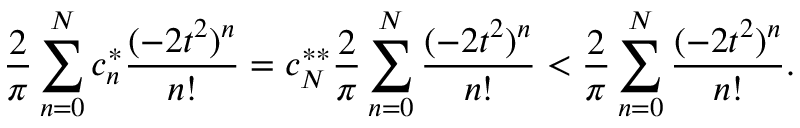<formula> <loc_0><loc_0><loc_500><loc_500>\frac { 2 } { \pi } \sum _ { n = 0 } ^ { N } c _ { n } ^ { * } \frac { ( - 2 t ^ { 2 } ) ^ { n } } { n ! } = c _ { N } ^ { * * } \frac { 2 } { \pi } \sum _ { n = 0 } ^ { N } \frac { ( - 2 t ^ { 2 } ) ^ { n } } { n ! } < \frac { 2 } { \pi } \sum _ { n = 0 } ^ { N } \frac { ( - 2 t ^ { 2 } ) ^ { n } } { n ! } .</formula> 